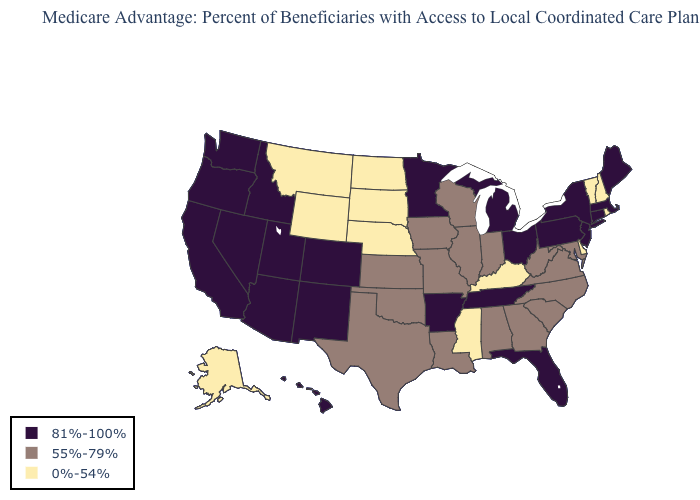What is the lowest value in states that border Utah?
Short answer required. 0%-54%. Which states have the lowest value in the USA?
Short answer required. Alaska, Delaware, Kentucky, Mississippi, Montana, North Dakota, Nebraska, New Hampshire, Rhode Island, South Dakota, Vermont, Wyoming. Among the states that border Minnesota , which have the lowest value?
Short answer required. North Dakota, South Dakota. Which states have the lowest value in the Northeast?
Concise answer only. New Hampshire, Rhode Island, Vermont. What is the value of Ohio?
Give a very brief answer. 81%-100%. Does the first symbol in the legend represent the smallest category?
Answer briefly. No. What is the highest value in states that border Indiana?
Short answer required. 81%-100%. Does Alaska have the highest value in the West?
Answer briefly. No. Does Connecticut have a higher value than South Dakota?
Keep it brief. Yes. Does Arizona have a lower value than Connecticut?
Keep it brief. No. Does Alaska have the highest value in the West?
Answer briefly. No. Is the legend a continuous bar?
Quick response, please. No. Name the states that have a value in the range 55%-79%?
Write a very short answer. Alabama, Georgia, Iowa, Illinois, Indiana, Kansas, Louisiana, Maryland, Missouri, North Carolina, Oklahoma, South Carolina, Texas, Virginia, Wisconsin, West Virginia. What is the highest value in the USA?
Answer briefly. 81%-100%. 